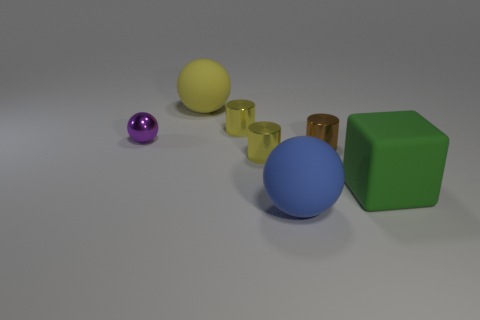Add 2 big green things. How many objects exist? 9 Subtract all balls. How many objects are left? 4 Subtract all tiny purple metallic things. Subtract all blue balls. How many objects are left? 5 Add 3 purple things. How many purple things are left? 4 Add 1 tiny green balls. How many tiny green balls exist? 1 Subtract 0 cyan spheres. How many objects are left? 7 